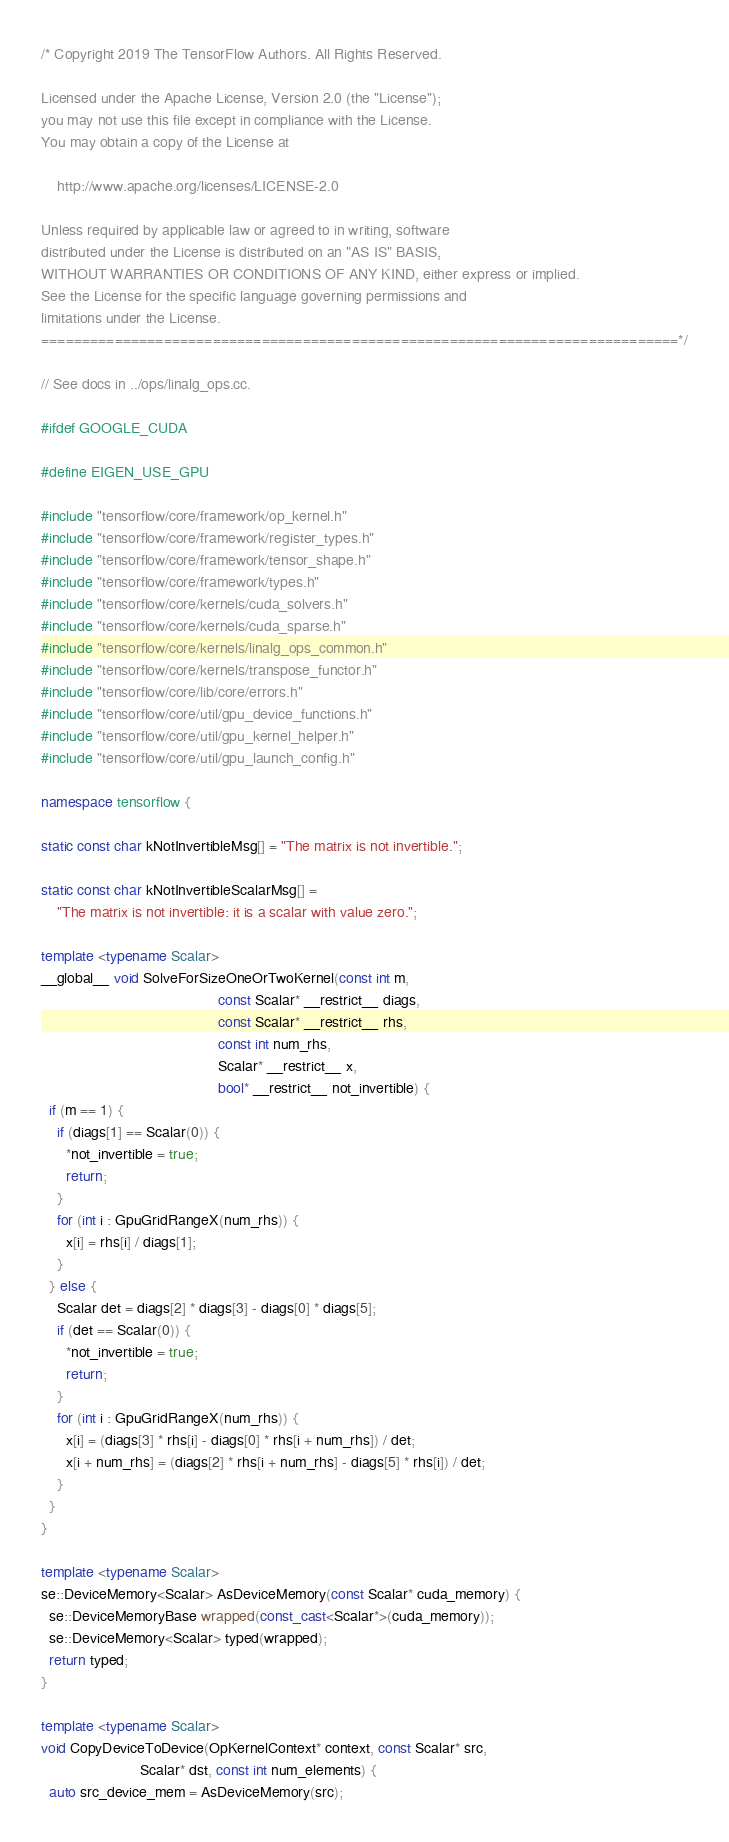<code> <loc_0><loc_0><loc_500><loc_500><_C++_>/* Copyright 2019 The TensorFlow Authors. All Rights Reserved.

Licensed under the Apache License, Version 2.0 (the "License");
you may not use this file except in compliance with the License.
You may obtain a copy of the License at

    http://www.apache.org/licenses/LICENSE-2.0

Unless required by applicable law or agreed to in writing, software
distributed under the License is distributed on an "AS IS" BASIS,
WITHOUT WARRANTIES OR CONDITIONS OF ANY KIND, either express or implied.
See the License for the specific language governing permissions and
limitations under the License.
==============================================================================*/

// See docs in ../ops/linalg_ops.cc.

#ifdef GOOGLE_CUDA

#define EIGEN_USE_GPU

#include "tensorflow/core/framework/op_kernel.h"
#include "tensorflow/core/framework/register_types.h"
#include "tensorflow/core/framework/tensor_shape.h"
#include "tensorflow/core/framework/types.h"
#include "tensorflow/core/kernels/cuda_solvers.h"
#include "tensorflow/core/kernels/cuda_sparse.h"
#include "tensorflow/core/kernels/linalg_ops_common.h"
#include "tensorflow/core/kernels/transpose_functor.h"
#include "tensorflow/core/lib/core/errors.h"
#include "tensorflow/core/util/gpu_device_functions.h"
#include "tensorflow/core/util/gpu_kernel_helper.h"
#include "tensorflow/core/util/gpu_launch_config.h"

namespace tensorflow {

static const char kNotInvertibleMsg[] = "The matrix is not invertible.";

static const char kNotInvertibleScalarMsg[] =
    "The matrix is not invertible: it is a scalar with value zero.";

template <typename Scalar>
__global__ void SolveForSizeOneOrTwoKernel(const int m,
                                           const Scalar* __restrict__ diags,
                                           const Scalar* __restrict__ rhs,
                                           const int num_rhs,
                                           Scalar* __restrict__ x,
                                           bool* __restrict__ not_invertible) {
  if (m == 1) {
    if (diags[1] == Scalar(0)) {
      *not_invertible = true;
      return;
    }
    for (int i : GpuGridRangeX(num_rhs)) {
      x[i] = rhs[i] / diags[1];
    }
  } else {
    Scalar det = diags[2] * diags[3] - diags[0] * diags[5];
    if (det == Scalar(0)) {
      *not_invertible = true;
      return;
    }
    for (int i : GpuGridRangeX(num_rhs)) {
      x[i] = (diags[3] * rhs[i] - diags[0] * rhs[i + num_rhs]) / det;
      x[i + num_rhs] = (diags[2] * rhs[i + num_rhs] - diags[5] * rhs[i]) / det;
    }
  }
}

template <typename Scalar>
se::DeviceMemory<Scalar> AsDeviceMemory(const Scalar* cuda_memory) {
  se::DeviceMemoryBase wrapped(const_cast<Scalar*>(cuda_memory));
  se::DeviceMemory<Scalar> typed(wrapped);
  return typed;
}

template <typename Scalar>
void CopyDeviceToDevice(OpKernelContext* context, const Scalar* src,
                        Scalar* dst, const int num_elements) {
  auto src_device_mem = AsDeviceMemory(src);</code> 